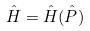<formula> <loc_0><loc_0><loc_500><loc_500>\hat { H } = \hat { H } ( \hat { P } )</formula> 